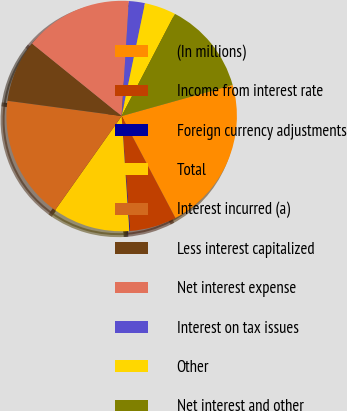Convert chart. <chart><loc_0><loc_0><loc_500><loc_500><pie_chart><fcel>(In millions)<fcel>Income from interest rate<fcel>Foreign currency adjustments<fcel>Total<fcel>Interest incurred (a)<fcel>Less interest capitalized<fcel>Net interest expense<fcel>Interest on tax issues<fcel>Other<fcel>Net interest and other<nl><fcel>21.63%<fcel>6.56%<fcel>0.1%<fcel>10.86%<fcel>17.32%<fcel>8.71%<fcel>15.17%<fcel>2.25%<fcel>4.4%<fcel>13.01%<nl></chart> 